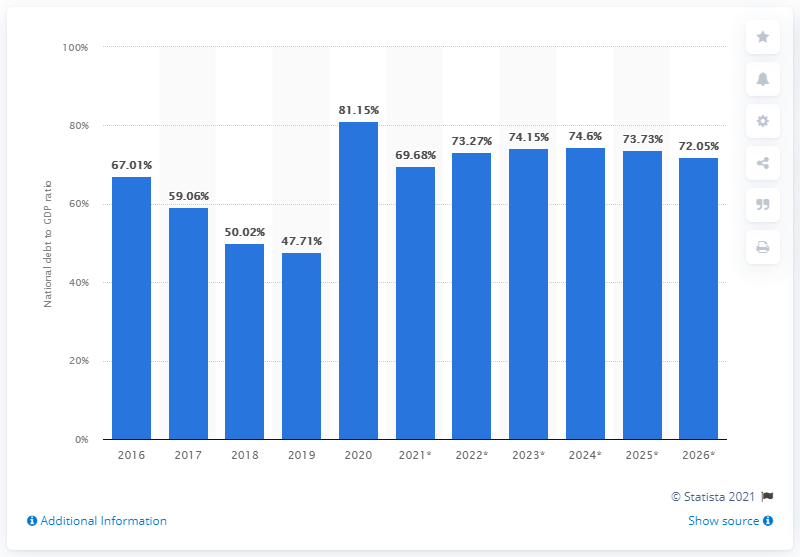List a handful of essential elements in this visual. In 2020, Iraq's debt to GDP ratio was 81.15%. 